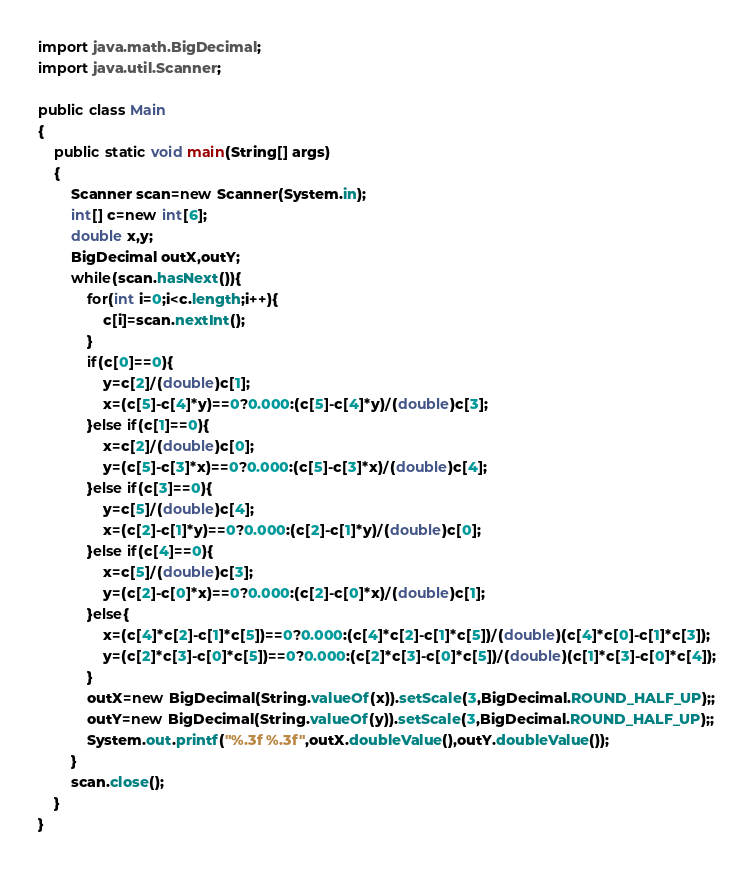<code> <loc_0><loc_0><loc_500><loc_500><_Java_>import java.math.BigDecimal;
import java.util.Scanner;

public class Main
{
	public static void main(String[] args)
	{
		Scanner scan=new Scanner(System.in);
		int[] c=new int[6];
		double x,y;
		BigDecimal outX,outY;
		while(scan.hasNext()){
			for(int i=0;i<c.length;i++){
				c[i]=scan.nextInt();
			}
			if(c[0]==0){
				y=c[2]/(double)c[1];
				x=(c[5]-c[4]*y)==0?0.000:(c[5]-c[4]*y)/(double)c[3];
			}else if(c[1]==0){
				x=c[2]/(double)c[0];
				y=(c[5]-c[3]*x)==0?0.000:(c[5]-c[3]*x)/(double)c[4];
			}else if(c[3]==0){
				y=c[5]/(double)c[4];
				x=(c[2]-c[1]*y)==0?0.000:(c[2]-c[1]*y)/(double)c[0];
			}else if(c[4]==0){
				x=c[5]/(double)c[3];
				y=(c[2]-c[0]*x)==0?0.000:(c[2]-c[0]*x)/(double)c[1];
			}else{
				x=(c[4]*c[2]-c[1]*c[5])==0?0.000:(c[4]*c[2]-c[1]*c[5])/(double)(c[4]*c[0]-c[1]*c[3]);
				y=(c[2]*c[3]-c[0]*c[5])==0?0.000:(c[2]*c[3]-c[0]*c[5])/(double)(c[1]*c[3]-c[0]*c[4]);
			}
			outX=new BigDecimal(String.valueOf(x)).setScale(3,BigDecimal.ROUND_HALF_UP);;
			outY=new BigDecimal(String.valueOf(y)).setScale(3,BigDecimal.ROUND_HALF_UP);;
			System.out.printf("%.3f %.3f",outX.doubleValue(),outY.doubleValue());
		}
		scan.close();
	}
}</code> 